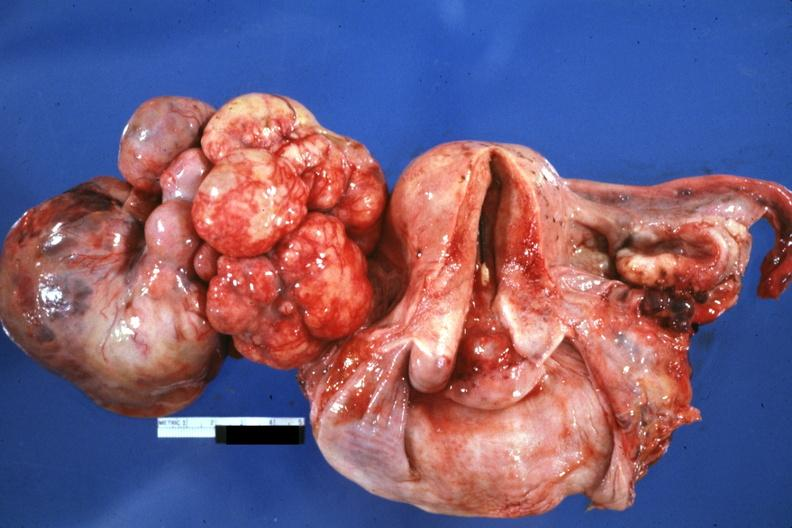s metastatic carcinoma present?
Answer the question using a single word or phrase. Yes 